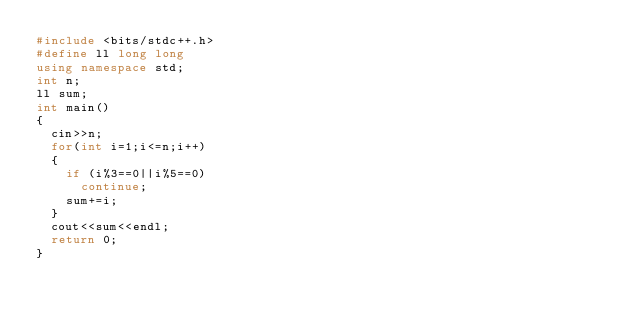Convert code to text. <code><loc_0><loc_0><loc_500><loc_500><_C++_>#include <bits/stdc++.h>
#define ll long long
using namespace std;
int n;
ll sum;
int main()
{
	cin>>n;
	for(int i=1;i<=n;i++)
	{
		if (i%3==0||i%5==0)
			continue;
		sum+=i;
	}
	cout<<sum<<endl;
	return 0;
}</code> 